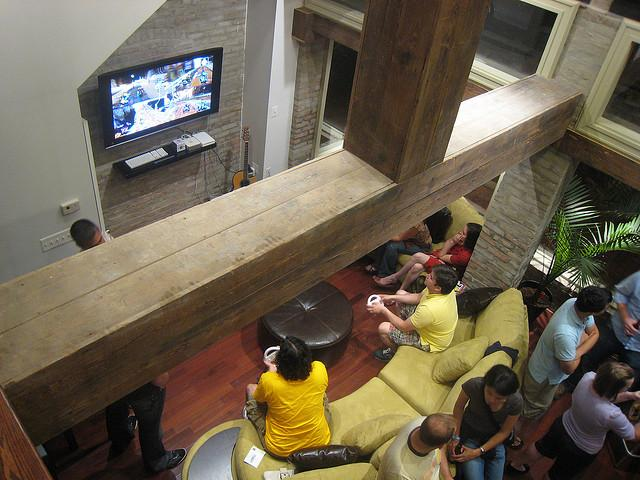The people sitting on the couch are competing in what on the television?

Choices:
A) tekken
B) street fighter
C) mario kart
D) smash brothers mario kart 